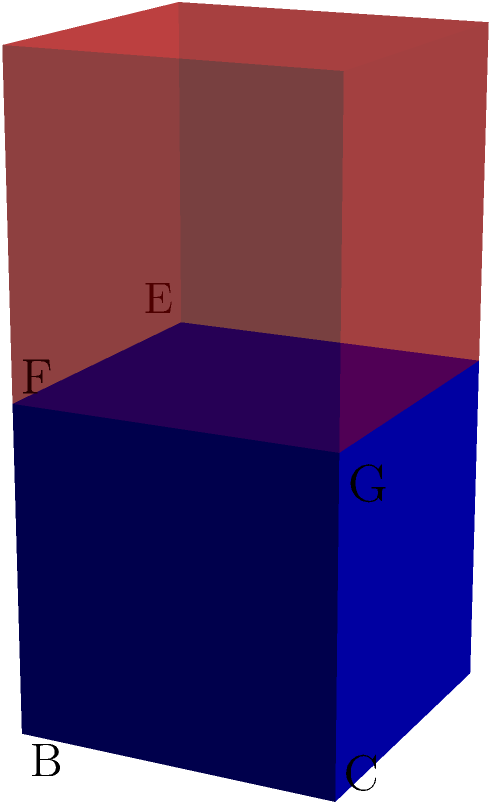Consider the symmetry group of a cube, which is isomorphic to the octahedral group $O$. Given that a 90-degree rotation around an axis passing through the center of a face is an element of order 4, how many elements of order 4 are there in the symmetry group of the cube? Relate this to Blandine Kriegel's concept of the "geometry of power" in political philosophy. To answer this question, let's approach it step-by-step:

1) First, we need to understand the structure of the symmetry group of a cube:
   - The symmetry group of a cube is isomorphic to the octahedral group $O$.
   - $|O| = 24$, meaning there are 24 symmetry operations in total.

2) Now, let's identify the rotations of order 4:
   - These are 90-degree rotations around axes passing through the centers of opposite faces.
   - There are 3 such axes: one connecting the centers of the front and back faces, one for top and bottom, and one for left and right.

3) For each axis, we have two possible 90-degree rotations: clockwise and counterclockwise.
   - This gives us $3 \times 2 = 6$ rotations of order 4.

4) Relating to Blandine Kriegel's concept of the "geometry of power":
   - Kriegel often discusses how political structures reflect geometric principles.
   - The symmetry of the cube can be seen as a metaphor for balanced power distribution.
   - The order 4 rotations represent transformations that maintain this balance while significantly altering the configuration, similar to major political shifts that preserve overall structure.

5) In this context, the 6 order-4 elements represent fundamental transformations in the "political cube" that maintain its essential structure while significantly altering its configuration.
Answer: 6 elements of order 4 